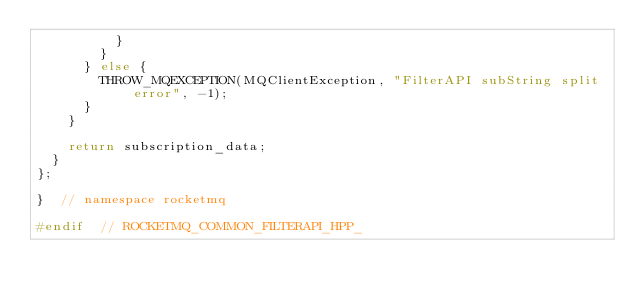Convert code to text. <code><loc_0><loc_0><loc_500><loc_500><_C++_>          }
        }
      } else {
        THROW_MQEXCEPTION(MQClientException, "FilterAPI subString split error", -1);
      }
    }

    return subscription_data;
  }
};

}  // namespace rocketmq

#endif  // ROCKETMQ_COMMON_FILTERAPI_HPP_
</code> 